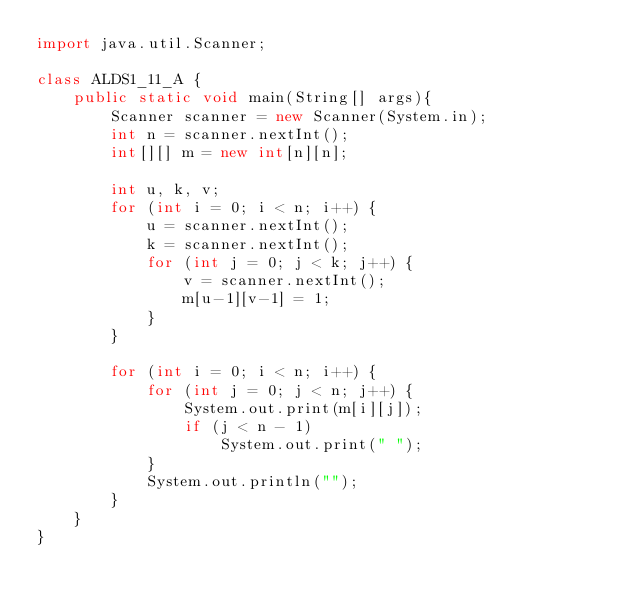<code> <loc_0><loc_0><loc_500><loc_500><_Java_>import java.util.Scanner;

class ALDS1_11_A {
    public static void main(String[] args){
        Scanner scanner = new Scanner(System.in);
        int n = scanner.nextInt();
        int[][] m = new int[n][n];

        int u, k, v;
        for (int i = 0; i < n; i++) {
            u = scanner.nextInt();
            k = scanner.nextInt();
            for (int j = 0; j < k; j++) {
                v = scanner.nextInt();
                m[u-1][v-1] = 1;
            }
        }

        for (int i = 0; i < n; i++) {
            for (int j = 0; j < n; j++) {
                System.out.print(m[i][j]);
                if (j < n - 1)
                    System.out.print(" ");
            }
            System.out.println("");
        }
    }
}</code> 